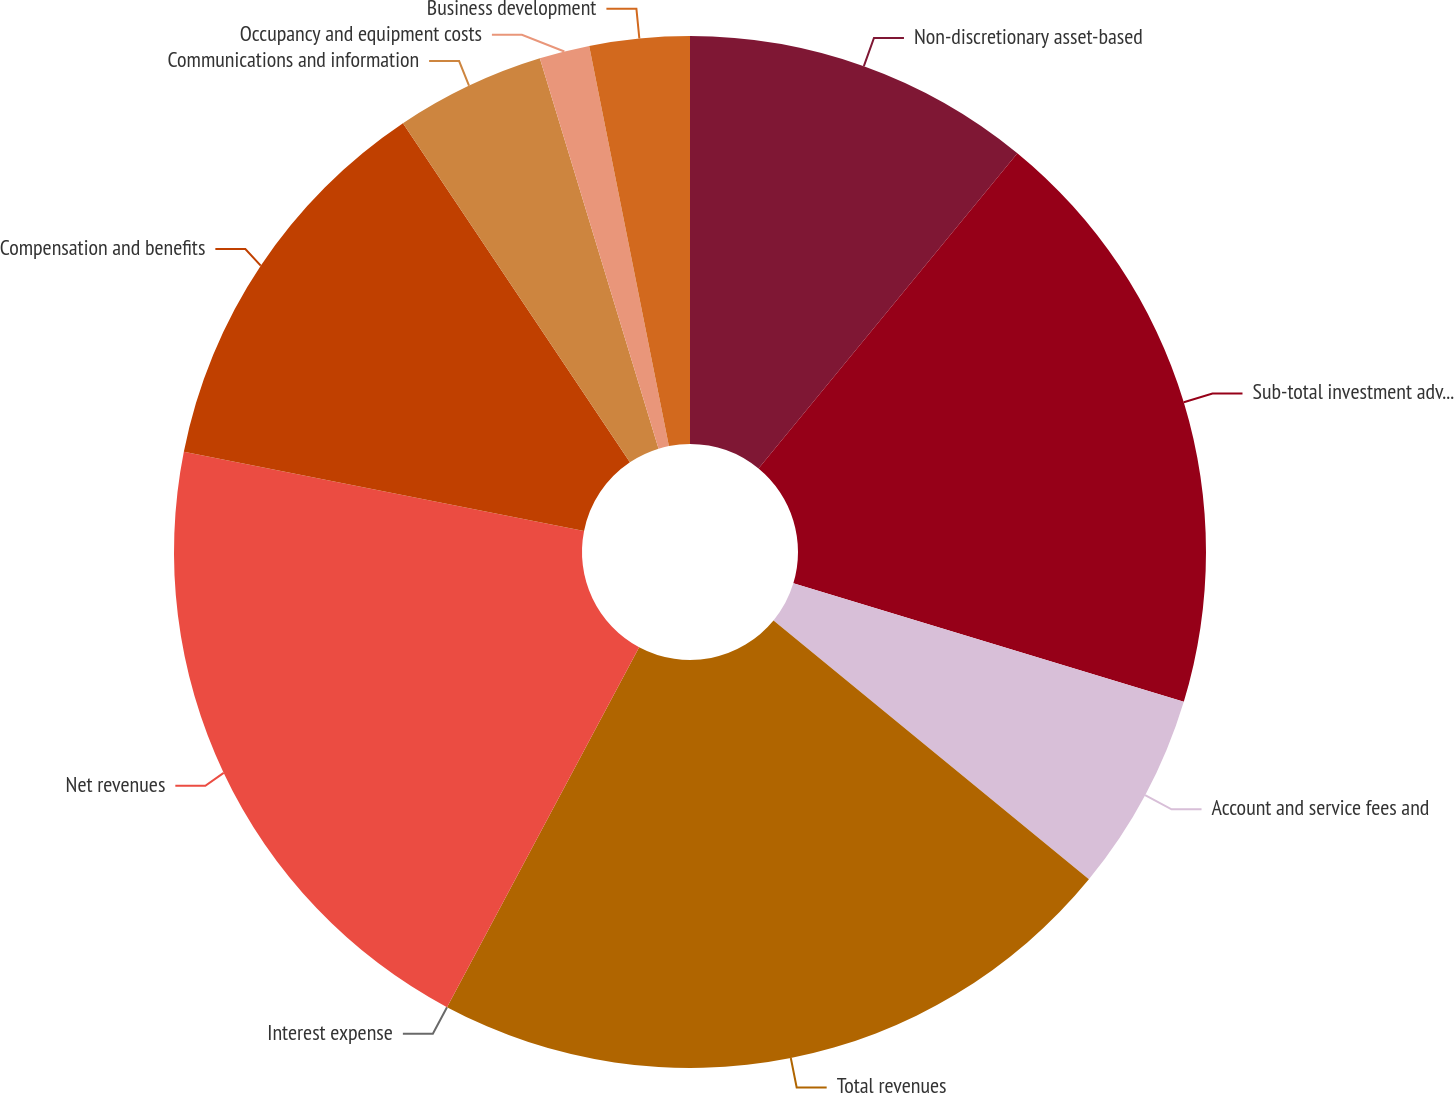Convert chart to OTSL. <chart><loc_0><loc_0><loc_500><loc_500><pie_chart><fcel>Non-discretionary asset-based<fcel>Sub-total investment advisory<fcel>Account and service fees and<fcel>Total revenues<fcel>Interest expense<fcel>Net revenues<fcel>Compensation and benefits<fcel>Communications and information<fcel>Occupancy and equipment costs<fcel>Business development<nl><fcel>10.94%<fcel>18.75%<fcel>6.25%<fcel>21.87%<fcel>0.0%<fcel>20.31%<fcel>12.5%<fcel>4.69%<fcel>1.57%<fcel>3.13%<nl></chart> 